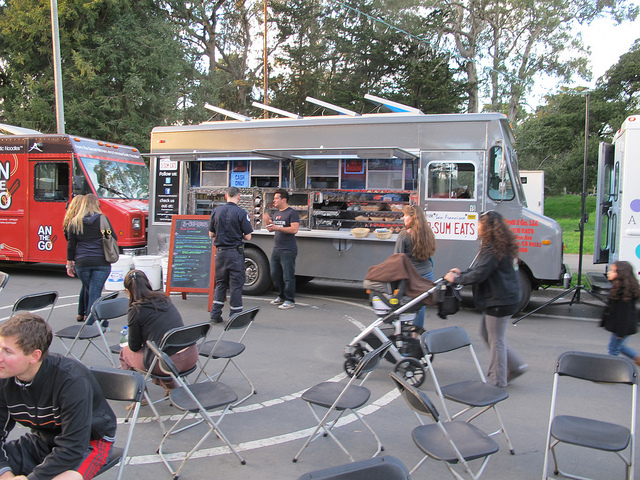Can you describe the atmosphere or environment based on this image? Certainly! The image depicts a casual outdoor eating environment, with customers standing or sitting on folding chairs as they wait for or enjoy their food. The presence of a bicycle suggests it’s a bike-friendly area, and there are trees in the background, indicating the food truck is likely parked in a place with some greenery, such as a park or urban outdoor space. 